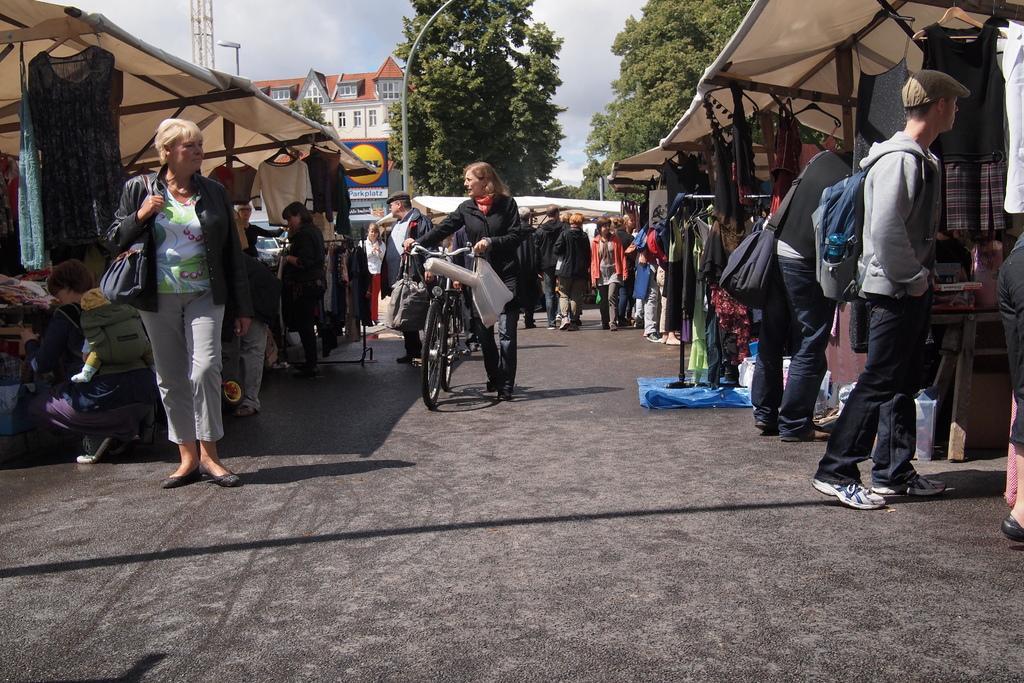Describe this image in one or two sentences. There are some persons on the road. Here we can see a woman holding a bicycle. There are stalls. In the background we can see a building, hoarding, poles, trees, and sky. 